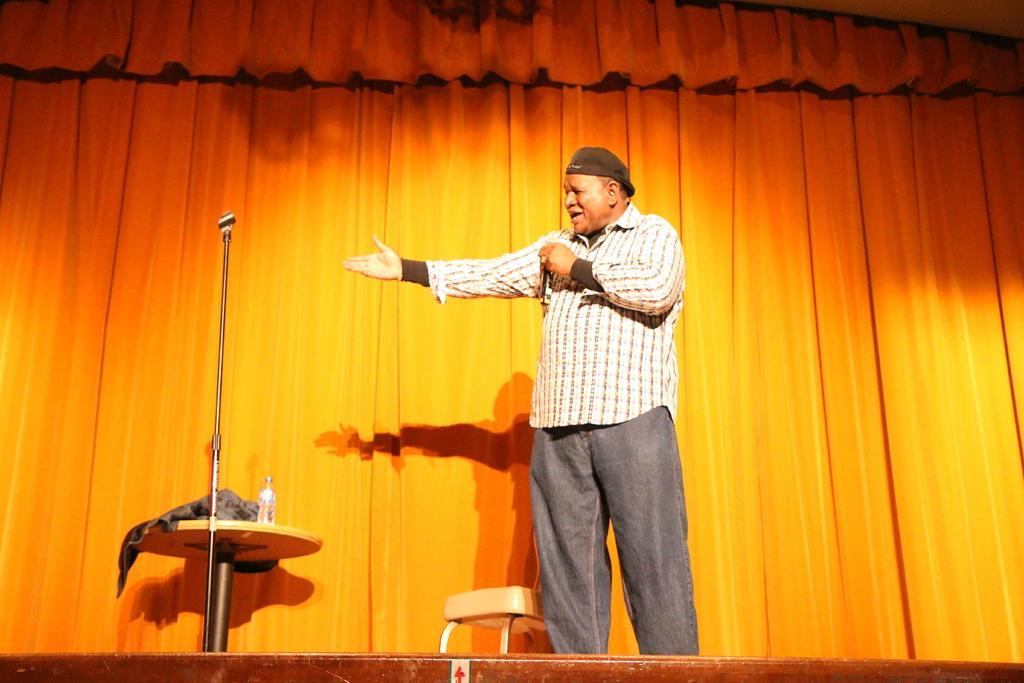Describe this image in one or two sentences. In this picture we can see man holding mic in his hand and talking and beside to him we have chair, table and on table there is bottle and in background we can see curtain. 